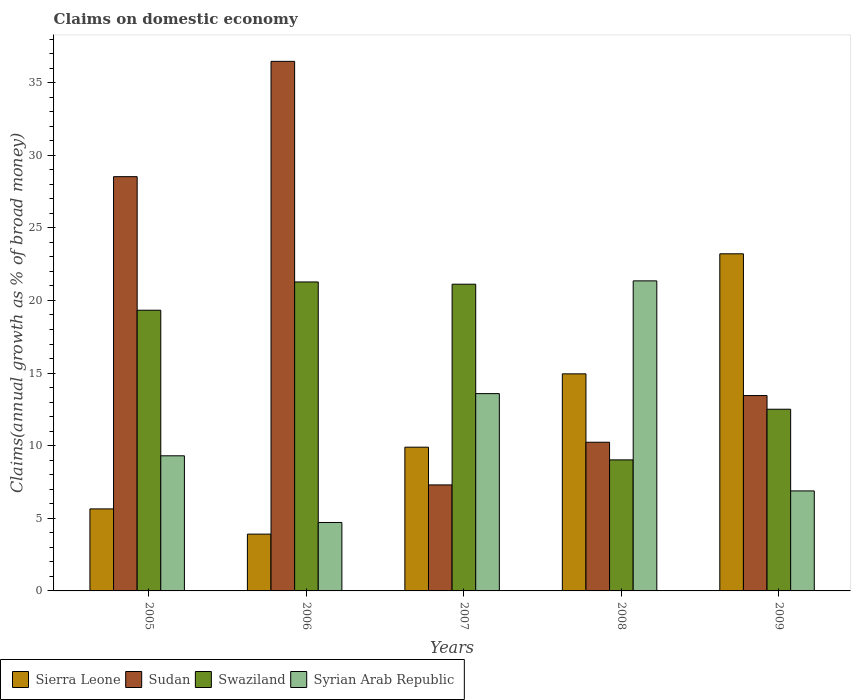How many groups of bars are there?
Keep it short and to the point. 5. What is the label of the 2nd group of bars from the left?
Provide a succinct answer. 2006. In how many cases, is the number of bars for a given year not equal to the number of legend labels?
Make the answer very short. 0. What is the percentage of broad money claimed on domestic economy in Syrian Arab Republic in 2009?
Offer a terse response. 6.89. Across all years, what is the maximum percentage of broad money claimed on domestic economy in Sierra Leone?
Ensure brevity in your answer.  23.21. Across all years, what is the minimum percentage of broad money claimed on domestic economy in Syrian Arab Republic?
Provide a succinct answer. 4.71. In which year was the percentage of broad money claimed on domestic economy in Syrian Arab Republic maximum?
Ensure brevity in your answer.  2008. What is the total percentage of broad money claimed on domestic economy in Syrian Arab Republic in the graph?
Provide a short and direct response. 55.84. What is the difference between the percentage of broad money claimed on domestic economy in Sierra Leone in 2007 and that in 2008?
Ensure brevity in your answer.  -5.05. What is the difference between the percentage of broad money claimed on domestic economy in Syrian Arab Republic in 2008 and the percentage of broad money claimed on domestic economy in Swaziland in 2005?
Keep it short and to the point. 2.02. What is the average percentage of broad money claimed on domestic economy in Swaziland per year?
Keep it short and to the point. 16.65. In the year 2007, what is the difference between the percentage of broad money claimed on domestic economy in Syrian Arab Republic and percentage of broad money claimed on domestic economy in Swaziland?
Make the answer very short. -7.53. In how many years, is the percentage of broad money claimed on domestic economy in Sierra Leone greater than 12 %?
Your answer should be very brief. 2. What is the ratio of the percentage of broad money claimed on domestic economy in Sierra Leone in 2007 to that in 2009?
Offer a terse response. 0.43. Is the percentage of broad money claimed on domestic economy in Swaziland in 2006 less than that in 2008?
Keep it short and to the point. No. What is the difference between the highest and the second highest percentage of broad money claimed on domestic economy in Sudan?
Make the answer very short. 7.94. What is the difference between the highest and the lowest percentage of broad money claimed on domestic economy in Sierra Leone?
Offer a terse response. 19.3. In how many years, is the percentage of broad money claimed on domestic economy in Sierra Leone greater than the average percentage of broad money claimed on domestic economy in Sierra Leone taken over all years?
Offer a terse response. 2. Is the sum of the percentage of broad money claimed on domestic economy in Syrian Arab Republic in 2008 and 2009 greater than the maximum percentage of broad money claimed on domestic economy in Swaziland across all years?
Offer a very short reply. Yes. Is it the case that in every year, the sum of the percentage of broad money claimed on domestic economy in Syrian Arab Republic and percentage of broad money claimed on domestic economy in Swaziland is greater than the sum of percentage of broad money claimed on domestic economy in Sierra Leone and percentage of broad money claimed on domestic economy in Sudan?
Your answer should be very brief. No. What does the 3rd bar from the left in 2007 represents?
Your answer should be compact. Swaziland. What does the 2nd bar from the right in 2005 represents?
Provide a succinct answer. Swaziland. Is it the case that in every year, the sum of the percentage of broad money claimed on domestic economy in Sudan and percentage of broad money claimed on domestic economy in Syrian Arab Republic is greater than the percentage of broad money claimed on domestic economy in Swaziland?
Your response must be concise. No. How many years are there in the graph?
Ensure brevity in your answer.  5. Does the graph contain any zero values?
Make the answer very short. No. Does the graph contain grids?
Your answer should be compact. No. Where does the legend appear in the graph?
Give a very brief answer. Bottom left. What is the title of the graph?
Give a very brief answer. Claims on domestic economy. Does "Italy" appear as one of the legend labels in the graph?
Make the answer very short. No. What is the label or title of the Y-axis?
Ensure brevity in your answer.  Claims(annual growth as % of broad money). What is the Claims(annual growth as % of broad money) of Sierra Leone in 2005?
Your response must be concise. 5.65. What is the Claims(annual growth as % of broad money) of Sudan in 2005?
Ensure brevity in your answer.  28.52. What is the Claims(annual growth as % of broad money) in Swaziland in 2005?
Offer a terse response. 19.33. What is the Claims(annual growth as % of broad money) in Syrian Arab Republic in 2005?
Your answer should be very brief. 9.3. What is the Claims(annual growth as % of broad money) in Sierra Leone in 2006?
Your response must be concise. 3.91. What is the Claims(annual growth as % of broad money) in Sudan in 2006?
Your response must be concise. 36.47. What is the Claims(annual growth as % of broad money) in Swaziland in 2006?
Ensure brevity in your answer.  21.27. What is the Claims(annual growth as % of broad money) of Syrian Arab Republic in 2006?
Give a very brief answer. 4.71. What is the Claims(annual growth as % of broad money) in Sierra Leone in 2007?
Your response must be concise. 9.9. What is the Claims(annual growth as % of broad money) of Sudan in 2007?
Your response must be concise. 7.3. What is the Claims(annual growth as % of broad money) of Swaziland in 2007?
Keep it short and to the point. 21.12. What is the Claims(annual growth as % of broad money) of Syrian Arab Republic in 2007?
Keep it short and to the point. 13.59. What is the Claims(annual growth as % of broad money) in Sierra Leone in 2008?
Your response must be concise. 14.95. What is the Claims(annual growth as % of broad money) of Sudan in 2008?
Your response must be concise. 10.24. What is the Claims(annual growth as % of broad money) of Swaziland in 2008?
Offer a very short reply. 9.02. What is the Claims(annual growth as % of broad money) of Syrian Arab Republic in 2008?
Offer a very short reply. 21.35. What is the Claims(annual growth as % of broad money) in Sierra Leone in 2009?
Your answer should be very brief. 23.21. What is the Claims(annual growth as % of broad money) of Sudan in 2009?
Your answer should be compact. 13.45. What is the Claims(annual growth as % of broad money) of Swaziland in 2009?
Give a very brief answer. 12.51. What is the Claims(annual growth as % of broad money) of Syrian Arab Republic in 2009?
Offer a very short reply. 6.89. Across all years, what is the maximum Claims(annual growth as % of broad money) in Sierra Leone?
Provide a short and direct response. 23.21. Across all years, what is the maximum Claims(annual growth as % of broad money) in Sudan?
Offer a terse response. 36.47. Across all years, what is the maximum Claims(annual growth as % of broad money) of Swaziland?
Offer a very short reply. 21.27. Across all years, what is the maximum Claims(annual growth as % of broad money) of Syrian Arab Republic?
Give a very brief answer. 21.35. Across all years, what is the minimum Claims(annual growth as % of broad money) of Sierra Leone?
Make the answer very short. 3.91. Across all years, what is the minimum Claims(annual growth as % of broad money) of Sudan?
Provide a succinct answer. 7.3. Across all years, what is the minimum Claims(annual growth as % of broad money) in Swaziland?
Provide a short and direct response. 9.02. Across all years, what is the minimum Claims(annual growth as % of broad money) in Syrian Arab Republic?
Your answer should be compact. 4.71. What is the total Claims(annual growth as % of broad money) of Sierra Leone in the graph?
Provide a succinct answer. 57.62. What is the total Claims(annual growth as % of broad money) in Sudan in the graph?
Provide a succinct answer. 95.98. What is the total Claims(annual growth as % of broad money) in Swaziland in the graph?
Ensure brevity in your answer.  83.26. What is the total Claims(annual growth as % of broad money) in Syrian Arab Republic in the graph?
Your answer should be compact. 55.84. What is the difference between the Claims(annual growth as % of broad money) of Sierra Leone in 2005 and that in 2006?
Offer a very short reply. 1.74. What is the difference between the Claims(annual growth as % of broad money) of Sudan in 2005 and that in 2006?
Offer a very short reply. -7.94. What is the difference between the Claims(annual growth as % of broad money) of Swaziland in 2005 and that in 2006?
Provide a short and direct response. -1.95. What is the difference between the Claims(annual growth as % of broad money) of Syrian Arab Republic in 2005 and that in 2006?
Keep it short and to the point. 4.59. What is the difference between the Claims(annual growth as % of broad money) of Sierra Leone in 2005 and that in 2007?
Offer a very short reply. -4.25. What is the difference between the Claims(annual growth as % of broad money) of Sudan in 2005 and that in 2007?
Offer a terse response. 21.23. What is the difference between the Claims(annual growth as % of broad money) of Swaziland in 2005 and that in 2007?
Offer a very short reply. -1.79. What is the difference between the Claims(annual growth as % of broad money) in Syrian Arab Republic in 2005 and that in 2007?
Make the answer very short. -4.28. What is the difference between the Claims(annual growth as % of broad money) of Sierra Leone in 2005 and that in 2008?
Give a very brief answer. -9.3. What is the difference between the Claims(annual growth as % of broad money) in Sudan in 2005 and that in 2008?
Offer a very short reply. 18.29. What is the difference between the Claims(annual growth as % of broad money) in Swaziland in 2005 and that in 2008?
Your answer should be compact. 10.31. What is the difference between the Claims(annual growth as % of broad money) in Syrian Arab Republic in 2005 and that in 2008?
Your answer should be very brief. -12.05. What is the difference between the Claims(annual growth as % of broad money) in Sierra Leone in 2005 and that in 2009?
Offer a very short reply. -17.57. What is the difference between the Claims(annual growth as % of broad money) in Sudan in 2005 and that in 2009?
Offer a very short reply. 15.07. What is the difference between the Claims(annual growth as % of broad money) of Swaziland in 2005 and that in 2009?
Make the answer very short. 6.82. What is the difference between the Claims(annual growth as % of broad money) in Syrian Arab Republic in 2005 and that in 2009?
Your answer should be compact. 2.42. What is the difference between the Claims(annual growth as % of broad money) in Sierra Leone in 2006 and that in 2007?
Make the answer very short. -5.99. What is the difference between the Claims(annual growth as % of broad money) in Sudan in 2006 and that in 2007?
Offer a terse response. 29.17. What is the difference between the Claims(annual growth as % of broad money) of Swaziland in 2006 and that in 2007?
Your answer should be very brief. 0.15. What is the difference between the Claims(annual growth as % of broad money) in Syrian Arab Republic in 2006 and that in 2007?
Your answer should be very brief. -8.87. What is the difference between the Claims(annual growth as % of broad money) in Sierra Leone in 2006 and that in 2008?
Your answer should be very brief. -11.04. What is the difference between the Claims(annual growth as % of broad money) of Sudan in 2006 and that in 2008?
Keep it short and to the point. 26.23. What is the difference between the Claims(annual growth as % of broad money) in Swaziland in 2006 and that in 2008?
Your answer should be compact. 12.25. What is the difference between the Claims(annual growth as % of broad money) in Syrian Arab Republic in 2006 and that in 2008?
Provide a succinct answer. -16.64. What is the difference between the Claims(annual growth as % of broad money) of Sierra Leone in 2006 and that in 2009?
Make the answer very short. -19.3. What is the difference between the Claims(annual growth as % of broad money) in Sudan in 2006 and that in 2009?
Your response must be concise. 23.01. What is the difference between the Claims(annual growth as % of broad money) of Swaziland in 2006 and that in 2009?
Offer a terse response. 8.76. What is the difference between the Claims(annual growth as % of broad money) of Syrian Arab Republic in 2006 and that in 2009?
Your response must be concise. -2.17. What is the difference between the Claims(annual growth as % of broad money) in Sierra Leone in 2007 and that in 2008?
Your answer should be compact. -5.05. What is the difference between the Claims(annual growth as % of broad money) in Sudan in 2007 and that in 2008?
Keep it short and to the point. -2.94. What is the difference between the Claims(annual growth as % of broad money) in Swaziland in 2007 and that in 2008?
Keep it short and to the point. 12.1. What is the difference between the Claims(annual growth as % of broad money) in Syrian Arab Republic in 2007 and that in 2008?
Provide a short and direct response. -7.76. What is the difference between the Claims(annual growth as % of broad money) in Sierra Leone in 2007 and that in 2009?
Offer a terse response. -13.32. What is the difference between the Claims(annual growth as % of broad money) in Sudan in 2007 and that in 2009?
Offer a terse response. -6.15. What is the difference between the Claims(annual growth as % of broad money) in Swaziland in 2007 and that in 2009?
Offer a terse response. 8.61. What is the difference between the Claims(annual growth as % of broad money) of Syrian Arab Republic in 2007 and that in 2009?
Provide a short and direct response. 6.7. What is the difference between the Claims(annual growth as % of broad money) of Sierra Leone in 2008 and that in 2009?
Your answer should be compact. -8.27. What is the difference between the Claims(annual growth as % of broad money) in Sudan in 2008 and that in 2009?
Keep it short and to the point. -3.22. What is the difference between the Claims(annual growth as % of broad money) of Swaziland in 2008 and that in 2009?
Provide a succinct answer. -3.49. What is the difference between the Claims(annual growth as % of broad money) of Syrian Arab Republic in 2008 and that in 2009?
Provide a succinct answer. 14.46. What is the difference between the Claims(annual growth as % of broad money) in Sierra Leone in 2005 and the Claims(annual growth as % of broad money) in Sudan in 2006?
Your answer should be compact. -30.82. What is the difference between the Claims(annual growth as % of broad money) in Sierra Leone in 2005 and the Claims(annual growth as % of broad money) in Swaziland in 2006?
Offer a very short reply. -15.63. What is the difference between the Claims(annual growth as % of broad money) in Sierra Leone in 2005 and the Claims(annual growth as % of broad money) in Syrian Arab Republic in 2006?
Make the answer very short. 0.93. What is the difference between the Claims(annual growth as % of broad money) of Sudan in 2005 and the Claims(annual growth as % of broad money) of Swaziland in 2006?
Keep it short and to the point. 7.25. What is the difference between the Claims(annual growth as % of broad money) of Sudan in 2005 and the Claims(annual growth as % of broad money) of Syrian Arab Republic in 2006?
Provide a short and direct response. 23.81. What is the difference between the Claims(annual growth as % of broad money) in Swaziland in 2005 and the Claims(annual growth as % of broad money) in Syrian Arab Republic in 2006?
Ensure brevity in your answer.  14.62. What is the difference between the Claims(annual growth as % of broad money) in Sierra Leone in 2005 and the Claims(annual growth as % of broad money) in Sudan in 2007?
Your answer should be compact. -1.65. What is the difference between the Claims(annual growth as % of broad money) of Sierra Leone in 2005 and the Claims(annual growth as % of broad money) of Swaziland in 2007?
Provide a short and direct response. -15.47. What is the difference between the Claims(annual growth as % of broad money) of Sierra Leone in 2005 and the Claims(annual growth as % of broad money) of Syrian Arab Republic in 2007?
Make the answer very short. -7.94. What is the difference between the Claims(annual growth as % of broad money) of Sudan in 2005 and the Claims(annual growth as % of broad money) of Swaziland in 2007?
Your response must be concise. 7.4. What is the difference between the Claims(annual growth as % of broad money) of Sudan in 2005 and the Claims(annual growth as % of broad money) of Syrian Arab Republic in 2007?
Offer a very short reply. 14.94. What is the difference between the Claims(annual growth as % of broad money) of Swaziland in 2005 and the Claims(annual growth as % of broad money) of Syrian Arab Republic in 2007?
Keep it short and to the point. 5.74. What is the difference between the Claims(annual growth as % of broad money) in Sierra Leone in 2005 and the Claims(annual growth as % of broad money) in Sudan in 2008?
Give a very brief answer. -4.59. What is the difference between the Claims(annual growth as % of broad money) in Sierra Leone in 2005 and the Claims(annual growth as % of broad money) in Swaziland in 2008?
Provide a succinct answer. -3.38. What is the difference between the Claims(annual growth as % of broad money) in Sierra Leone in 2005 and the Claims(annual growth as % of broad money) in Syrian Arab Republic in 2008?
Ensure brevity in your answer.  -15.7. What is the difference between the Claims(annual growth as % of broad money) in Sudan in 2005 and the Claims(annual growth as % of broad money) in Swaziland in 2008?
Give a very brief answer. 19.5. What is the difference between the Claims(annual growth as % of broad money) of Sudan in 2005 and the Claims(annual growth as % of broad money) of Syrian Arab Republic in 2008?
Make the answer very short. 7.17. What is the difference between the Claims(annual growth as % of broad money) in Swaziland in 2005 and the Claims(annual growth as % of broad money) in Syrian Arab Republic in 2008?
Your answer should be very brief. -2.02. What is the difference between the Claims(annual growth as % of broad money) in Sierra Leone in 2005 and the Claims(annual growth as % of broad money) in Sudan in 2009?
Make the answer very short. -7.81. What is the difference between the Claims(annual growth as % of broad money) in Sierra Leone in 2005 and the Claims(annual growth as % of broad money) in Swaziland in 2009?
Make the answer very short. -6.86. What is the difference between the Claims(annual growth as % of broad money) of Sierra Leone in 2005 and the Claims(annual growth as % of broad money) of Syrian Arab Republic in 2009?
Make the answer very short. -1.24. What is the difference between the Claims(annual growth as % of broad money) of Sudan in 2005 and the Claims(annual growth as % of broad money) of Swaziland in 2009?
Provide a short and direct response. 16.01. What is the difference between the Claims(annual growth as % of broad money) of Sudan in 2005 and the Claims(annual growth as % of broad money) of Syrian Arab Republic in 2009?
Provide a succinct answer. 21.64. What is the difference between the Claims(annual growth as % of broad money) of Swaziland in 2005 and the Claims(annual growth as % of broad money) of Syrian Arab Republic in 2009?
Your answer should be compact. 12.44. What is the difference between the Claims(annual growth as % of broad money) in Sierra Leone in 2006 and the Claims(annual growth as % of broad money) in Sudan in 2007?
Provide a succinct answer. -3.39. What is the difference between the Claims(annual growth as % of broad money) of Sierra Leone in 2006 and the Claims(annual growth as % of broad money) of Swaziland in 2007?
Make the answer very short. -17.21. What is the difference between the Claims(annual growth as % of broad money) of Sierra Leone in 2006 and the Claims(annual growth as % of broad money) of Syrian Arab Republic in 2007?
Ensure brevity in your answer.  -9.67. What is the difference between the Claims(annual growth as % of broad money) in Sudan in 2006 and the Claims(annual growth as % of broad money) in Swaziland in 2007?
Make the answer very short. 15.35. What is the difference between the Claims(annual growth as % of broad money) of Sudan in 2006 and the Claims(annual growth as % of broad money) of Syrian Arab Republic in 2007?
Give a very brief answer. 22.88. What is the difference between the Claims(annual growth as % of broad money) of Swaziland in 2006 and the Claims(annual growth as % of broad money) of Syrian Arab Republic in 2007?
Ensure brevity in your answer.  7.69. What is the difference between the Claims(annual growth as % of broad money) in Sierra Leone in 2006 and the Claims(annual growth as % of broad money) in Sudan in 2008?
Offer a terse response. -6.33. What is the difference between the Claims(annual growth as % of broad money) of Sierra Leone in 2006 and the Claims(annual growth as % of broad money) of Swaziland in 2008?
Provide a succinct answer. -5.11. What is the difference between the Claims(annual growth as % of broad money) in Sierra Leone in 2006 and the Claims(annual growth as % of broad money) in Syrian Arab Republic in 2008?
Your answer should be very brief. -17.44. What is the difference between the Claims(annual growth as % of broad money) in Sudan in 2006 and the Claims(annual growth as % of broad money) in Swaziland in 2008?
Provide a succinct answer. 27.44. What is the difference between the Claims(annual growth as % of broad money) in Sudan in 2006 and the Claims(annual growth as % of broad money) in Syrian Arab Republic in 2008?
Your response must be concise. 15.12. What is the difference between the Claims(annual growth as % of broad money) in Swaziland in 2006 and the Claims(annual growth as % of broad money) in Syrian Arab Republic in 2008?
Ensure brevity in your answer.  -0.08. What is the difference between the Claims(annual growth as % of broad money) of Sierra Leone in 2006 and the Claims(annual growth as % of broad money) of Sudan in 2009?
Make the answer very short. -9.54. What is the difference between the Claims(annual growth as % of broad money) of Sierra Leone in 2006 and the Claims(annual growth as % of broad money) of Swaziland in 2009?
Give a very brief answer. -8.6. What is the difference between the Claims(annual growth as % of broad money) in Sierra Leone in 2006 and the Claims(annual growth as % of broad money) in Syrian Arab Republic in 2009?
Your response must be concise. -2.97. What is the difference between the Claims(annual growth as % of broad money) of Sudan in 2006 and the Claims(annual growth as % of broad money) of Swaziland in 2009?
Provide a succinct answer. 23.95. What is the difference between the Claims(annual growth as % of broad money) of Sudan in 2006 and the Claims(annual growth as % of broad money) of Syrian Arab Republic in 2009?
Provide a short and direct response. 29.58. What is the difference between the Claims(annual growth as % of broad money) in Swaziland in 2006 and the Claims(annual growth as % of broad money) in Syrian Arab Republic in 2009?
Keep it short and to the point. 14.39. What is the difference between the Claims(annual growth as % of broad money) in Sierra Leone in 2007 and the Claims(annual growth as % of broad money) in Sudan in 2008?
Your answer should be compact. -0.34. What is the difference between the Claims(annual growth as % of broad money) in Sierra Leone in 2007 and the Claims(annual growth as % of broad money) in Swaziland in 2008?
Offer a terse response. 0.87. What is the difference between the Claims(annual growth as % of broad money) of Sierra Leone in 2007 and the Claims(annual growth as % of broad money) of Syrian Arab Republic in 2008?
Offer a very short reply. -11.45. What is the difference between the Claims(annual growth as % of broad money) of Sudan in 2007 and the Claims(annual growth as % of broad money) of Swaziland in 2008?
Offer a terse response. -1.72. What is the difference between the Claims(annual growth as % of broad money) in Sudan in 2007 and the Claims(annual growth as % of broad money) in Syrian Arab Republic in 2008?
Offer a terse response. -14.05. What is the difference between the Claims(annual growth as % of broad money) of Swaziland in 2007 and the Claims(annual growth as % of broad money) of Syrian Arab Republic in 2008?
Your answer should be very brief. -0.23. What is the difference between the Claims(annual growth as % of broad money) in Sierra Leone in 2007 and the Claims(annual growth as % of broad money) in Sudan in 2009?
Make the answer very short. -3.56. What is the difference between the Claims(annual growth as % of broad money) in Sierra Leone in 2007 and the Claims(annual growth as % of broad money) in Swaziland in 2009?
Offer a terse response. -2.61. What is the difference between the Claims(annual growth as % of broad money) of Sierra Leone in 2007 and the Claims(annual growth as % of broad money) of Syrian Arab Republic in 2009?
Provide a succinct answer. 3.01. What is the difference between the Claims(annual growth as % of broad money) of Sudan in 2007 and the Claims(annual growth as % of broad money) of Swaziland in 2009?
Provide a succinct answer. -5.21. What is the difference between the Claims(annual growth as % of broad money) of Sudan in 2007 and the Claims(annual growth as % of broad money) of Syrian Arab Republic in 2009?
Ensure brevity in your answer.  0.41. What is the difference between the Claims(annual growth as % of broad money) of Swaziland in 2007 and the Claims(annual growth as % of broad money) of Syrian Arab Republic in 2009?
Offer a very short reply. 14.23. What is the difference between the Claims(annual growth as % of broad money) in Sierra Leone in 2008 and the Claims(annual growth as % of broad money) in Sudan in 2009?
Offer a very short reply. 1.49. What is the difference between the Claims(annual growth as % of broad money) in Sierra Leone in 2008 and the Claims(annual growth as % of broad money) in Swaziland in 2009?
Your answer should be very brief. 2.44. What is the difference between the Claims(annual growth as % of broad money) in Sierra Leone in 2008 and the Claims(annual growth as % of broad money) in Syrian Arab Republic in 2009?
Give a very brief answer. 8.06. What is the difference between the Claims(annual growth as % of broad money) in Sudan in 2008 and the Claims(annual growth as % of broad money) in Swaziland in 2009?
Your answer should be very brief. -2.27. What is the difference between the Claims(annual growth as % of broad money) in Sudan in 2008 and the Claims(annual growth as % of broad money) in Syrian Arab Republic in 2009?
Give a very brief answer. 3.35. What is the difference between the Claims(annual growth as % of broad money) of Swaziland in 2008 and the Claims(annual growth as % of broad money) of Syrian Arab Republic in 2009?
Offer a terse response. 2.14. What is the average Claims(annual growth as % of broad money) of Sierra Leone per year?
Your answer should be very brief. 11.52. What is the average Claims(annual growth as % of broad money) of Sudan per year?
Provide a short and direct response. 19.2. What is the average Claims(annual growth as % of broad money) in Swaziland per year?
Your response must be concise. 16.65. What is the average Claims(annual growth as % of broad money) of Syrian Arab Republic per year?
Keep it short and to the point. 11.17. In the year 2005, what is the difference between the Claims(annual growth as % of broad money) of Sierra Leone and Claims(annual growth as % of broad money) of Sudan?
Your response must be concise. -22.88. In the year 2005, what is the difference between the Claims(annual growth as % of broad money) of Sierra Leone and Claims(annual growth as % of broad money) of Swaziland?
Offer a terse response. -13.68. In the year 2005, what is the difference between the Claims(annual growth as % of broad money) of Sierra Leone and Claims(annual growth as % of broad money) of Syrian Arab Republic?
Your response must be concise. -3.66. In the year 2005, what is the difference between the Claims(annual growth as % of broad money) in Sudan and Claims(annual growth as % of broad money) in Swaziland?
Offer a very short reply. 9.2. In the year 2005, what is the difference between the Claims(annual growth as % of broad money) of Sudan and Claims(annual growth as % of broad money) of Syrian Arab Republic?
Your response must be concise. 19.22. In the year 2005, what is the difference between the Claims(annual growth as % of broad money) in Swaziland and Claims(annual growth as % of broad money) in Syrian Arab Republic?
Ensure brevity in your answer.  10.02. In the year 2006, what is the difference between the Claims(annual growth as % of broad money) of Sierra Leone and Claims(annual growth as % of broad money) of Sudan?
Make the answer very short. -32.55. In the year 2006, what is the difference between the Claims(annual growth as % of broad money) in Sierra Leone and Claims(annual growth as % of broad money) in Swaziland?
Offer a terse response. -17.36. In the year 2006, what is the difference between the Claims(annual growth as % of broad money) of Sierra Leone and Claims(annual growth as % of broad money) of Syrian Arab Republic?
Provide a short and direct response. -0.8. In the year 2006, what is the difference between the Claims(annual growth as % of broad money) of Sudan and Claims(annual growth as % of broad money) of Swaziland?
Make the answer very short. 15.19. In the year 2006, what is the difference between the Claims(annual growth as % of broad money) of Sudan and Claims(annual growth as % of broad money) of Syrian Arab Republic?
Give a very brief answer. 31.75. In the year 2006, what is the difference between the Claims(annual growth as % of broad money) of Swaziland and Claims(annual growth as % of broad money) of Syrian Arab Republic?
Provide a succinct answer. 16.56. In the year 2007, what is the difference between the Claims(annual growth as % of broad money) of Sierra Leone and Claims(annual growth as % of broad money) of Sudan?
Your answer should be compact. 2.6. In the year 2007, what is the difference between the Claims(annual growth as % of broad money) of Sierra Leone and Claims(annual growth as % of broad money) of Swaziland?
Provide a succinct answer. -11.22. In the year 2007, what is the difference between the Claims(annual growth as % of broad money) of Sierra Leone and Claims(annual growth as % of broad money) of Syrian Arab Republic?
Ensure brevity in your answer.  -3.69. In the year 2007, what is the difference between the Claims(annual growth as % of broad money) of Sudan and Claims(annual growth as % of broad money) of Swaziland?
Ensure brevity in your answer.  -13.82. In the year 2007, what is the difference between the Claims(annual growth as % of broad money) in Sudan and Claims(annual growth as % of broad money) in Syrian Arab Republic?
Offer a very short reply. -6.29. In the year 2007, what is the difference between the Claims(annual growth as % of broad money) in Swaziland and Claims(annual growth as % of broad money) in Syrian Arab Republic?
Keep it short and to the point. 7.53. In the year 2008, what is the difference between the Claims(annual growth as % of broad money) in Sierra Leone and Claims(annual growth as % of broad money) in Sudan?
Your answer should be very brief. 4.71. In the year 2008, what is the difference between the Claims(annual growth as % of broad money) of Sierra Leone and Claims(annual growth as % of broad money) of Swaziland?
Keep it short and to the point. 5.92. In the year 2008, what is the difference between the Claims(annual growth as % of broad money) of Sierra Leone and Claims(annual growth as % of broad money) of Syrian Arab Republic?
Give a very brief answer. -6.4. In the year 2008, what is the difference between the Claims(annual growth as % of broad money) of Sudan and Claims(annual growth as % of broad money) of Swaziland?
Keep it short and to the point. 1.21. In the year 2008, what is the difference between the Claims(annual growth as % of broad money) in Sudan and Claims(annual growth as % of broad money) in Syrian Arab Republic?
Keep it short and to the point. -11.11. In the year 2008, what is the difference between the Claims(annual growth as % of broad money) in Swaziland and Claims(annual growth as % of broad money) in Syrian Arab Republic?
Provide a short and direct response. -12.33. In the year 2009, what is the difference between the Claims(annual growth as % of broad money) in Sierra Leone and Claims(annual growth as % of broad money) in Sudan?
Give a very brief answer. 9.76. In the year 2009, what is the difference between the Claims(annual growth as % of broad money) of Sierra Leone and Claims(annual growth as % of broad money) of Swaziland?
Your answer should be compact. 10.7. In the year 2009, what is the difference between the Claims(annual growth as % of broad money) of Sierra Leone and Claims(annual growth as % of broad money) of Syrian Arab Republic?
Your answer should be very brief. 16.33. In the year 2009, what is the difference between the Claims(annual growth as % of broad money) of Sudan and Claims(annual growth as % of broad money) of Swaziland?
Give a very brief answer. 0.94. In the year 2009, what is the difference between the Claims(annual growth as % of broad money) of Sudan and Claims(annual growth as % of broad money) of Syrian Arab Republic?
Make the answer very short. 6.57. In the year 2009, what is the difference between the Claims(annual growth as % of broad money) in Swaziland and Claims(annual growth as % of broad money) in Syrian Arab Republic?
Make the answer very short. 5.63. What is the ratio of the Claims(annual growth as % of broad money) of Sierra Leone in 2005 to that in 2006?
Give a very brief answer. 1.44. What is the ratio of the Claims(annual growth as % of broad money) of Sudan in 2005 to that in 2006?
Your answer should be compact. 0.78. What is the ratio of the Claims(annual growth as % of broad money) of Swaziland in 2005 to that in 2006?
Offer a terse response. 0.91. What is the ratio of the Claims(annual growth as % of broad money) of Syrian Arab Republic in 2005 to that in 2006?
Make the answer very short. 1.97. What is the ratio of the Claims(annual growth as % of broad money) in Sierra Leone in 2005 to that in 2007?
Make the answer very short. 0.57. What is the ratio of the Claims(annual growth as % of broad money) in Sudan in 2005 to that in 2007?
Your answer should be very brief. 3.91. What is the ratio of the Claims(annual growth as % of broad money) of Swaziland in 2005 to that in 2007?
Provide a succinct answer. 0.92. What is the ratio of the Claims(annual growth as % of broad money) of Syrian Arab Republic in 2005 to that in 2007?
Keep it short and to the point. 0.68. What is the ratio of the Claims(annual growth as % of broad money) in Sierra Leone in 2005 to that in 2008?
Your answer should be very brief. 0.38. What is the ratio of the Claims(annual growth as % of broad money) of Sudan in 2005 to that in 2008?
Give a very brief answer. 2.79. What is the ratio of the Claims(annual growth as % of broad money) of Swaziland in 2005 to that in 2008?
Give a very brief answer. 2.14. What is the ratio of the Claims(annual growth as % of broad money) in Syrian Arab Republic in 2005 to that in 2008?
Give a very brief answer. 0.44. What is the ratio of the Claims(annual growth as % of broad money) of Sierra Leone in 2005 to that in 2009?
Provide a short and direct response. 0.24. What is the ratio of the Claims(annual growth as % of broad money) in Sudan in 2005 to that in 2009?
Give a very brief answer. 2.12. What is the ratio of the Claims(annual growth as % of broad money) in Swaziland in 2005 to that in 2009?
Your answer should be compact. 1.54. What is the ratio of the Claims(annual growth as % of broad money) in Syrian Arab Republic in 2005 to that in 2009?
Provide a succinct answer. 1.35. What is the ratio of the Claims(annual growth as % of broad money) of Sierra Leone in 2006 to that in 2007?
Offer a very short reply. 0.4. What is the ratio of the Claims(annual growth as % of broad money) in Sudan in 2006 to that in 2007?
Your response must be concise. 5. What is the ratio of the Claims(annual growth as % of broad money) of Swaziland in 2006 to that in 2007?
Your response must be concise. 1.01. What is the ratio of the Claims(annual growth as % of broad money) in Syrian Arab Republic in 2006 to that in 2007?
Offer a very short reply. 0.35. What is the ratio of the Claims(annual growth as % of broad money) of Sierra Leone in 2006 to that in 2008?
Offer a very short reply. 0.26. What is the ratio of the Claims(annual growth as % of broad money) in Sudan in 2006 to that in 2008?
Ensure brevity in your answer.  3.56. What is the ratio of the Claims(annual growth as % of broad money) in Swaziland in 2006 to that in 2008?
Offer a very short reply. 2.36. What is the ratio of the Claims(annual growth as % of broad money) in Syrian Arab Republic in 2006 to that in 2008?
Provide a succinct answer. 0.22. What is the ratio of the Claims(annual growth as % of broad money) in Sierra Leone in 2006 to that in 2009?
Offer a very short reply. 0.17. What is the ratio of the Claims(annual growth as % of broad money) in Sudan in 2006 to that in 2009?
Offer a very short reply. 2.71. What is the ratio of the Claims(annual growth as % of broad money) in Swaziland in 2006 to that in 2009?
Ensure brevity in your answer.  1.7. What is the ratio of the Claims(annual growth as % of broad money) of Syrian Arab Republic in 2006 to that in 2009?
Keep it short and to the point. 0.68. What is the ratio of the Claims(annual growth as % of broad money) of Sierra Leone in 2007 to that in 2008?
Ensure brevity in your answer.  0.66. What is the ratio of the Claims(annual growth as % of broad money) in Sudan in 2007 to that in 2008?
Your answer should be compact. 0.71. What is the ratio of the Claims(annual growth as % of broad money) in Swaziland in 2007 to that in 2008?
Keep it short and to the point. 2.34. What is the ratio of the Claims(annual growth as % of broad money) in Syrian Arab Republic in 2007 to that in 2008?
Make the answer very short. 0.64. What is the ratio of the Claims(annual growth as % of broad money) in Sierra Leone in 2007 to that in 2009?
Offer a terse response. 0.43. What is the ratio of the Claims(annual growth as % of broad money) in Sudan in 2007 to that in 2009?
Offer a very short reply. 0.54. What is the ratio of the Claims(annual growth as % of broad money) in Swaziland in 2007 to that in 2009?
Your response must be concise. 1.69. What is the ratio of the Claims(annual growth as % of broad money) of Syrian Arab Republic in 2007 to that in 2009?
Keep it short and to the point. 1.97. What is the ratio of the Claims(annual growth as % of broad money) in Sierra Leone in 2008 to that in 2009?
Offer a terse response. 0.64. What is the ratio of the Claims(annual growth as % of broad money) in Sudan in 2008 to that in 2009?
Provide a succinct answer. 0.76. What is the ratio of the Claims(annual growth as % of broad money) in Swaziland in 2008 to that in 2009?
Provide a succinct answer. 0.72. What is the ratio of the Claims(annual growth as % of broad money) in Syrian Arab Republic in 2008 to that in 2009?
Provide a succinct answer. 3.1. What is the difference between the highest and the second highest Claims(annual growth as % of broad money) in Sierra Leone?
Provide a short and direct response. 8.27. What is the difference between the highest and the second highest Claims(annual growth as % of broad money) in Sudan?
Give a very brief answer. 7.94. What is the difference between the highest and the second highest Claims(annual growth as % of broad money) of Swaziland?
Your answer should be compact. 0.15. What is the difference between the highest and the second highest Claims(annual growth as % of broad money) of Syrian Arab Republic?
Offer a very short reply. 7.76. What is the difference between the highest and the lowest Claims(annual growth as % of broad money) in Sierra Leone?
Your response must be concise. 19.3. What is the difference between the highest and the lowest Claims(annual growth as % of broad money) in Sudan?
Keep it short and to the point. 29.17. What is the difference between the highest and the lowest Claims(annual growth as % of broad money) of Swaziland?
Make the answer very short. 12.25. What is the difference between the highest and the lowest Claims(annual growth as % of broad money) of Syrian Arab Republic?
Ensure brevity in your answer.  16.64. 